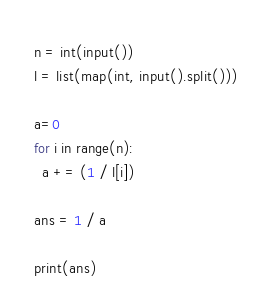Convert code to text. <code><loc_0><loc_0><loc_500><loc_500><_Python_>n = int(input())
l = list(map(int, input().split()))

a=0
for i in range(n):
  a += (1 / l[i])

ans = 1 / a

print(ans)</code> 